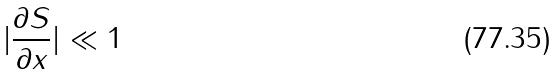Convert formula to latex. <formula><loc_0><loc_0><loc_500><loc_500>| \frac { \partial S } { \partial x } | \ll 1</formula> 